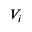<formula> <loc_0><loc_0><loc_500><loc_500>V _ { i }</formula> 